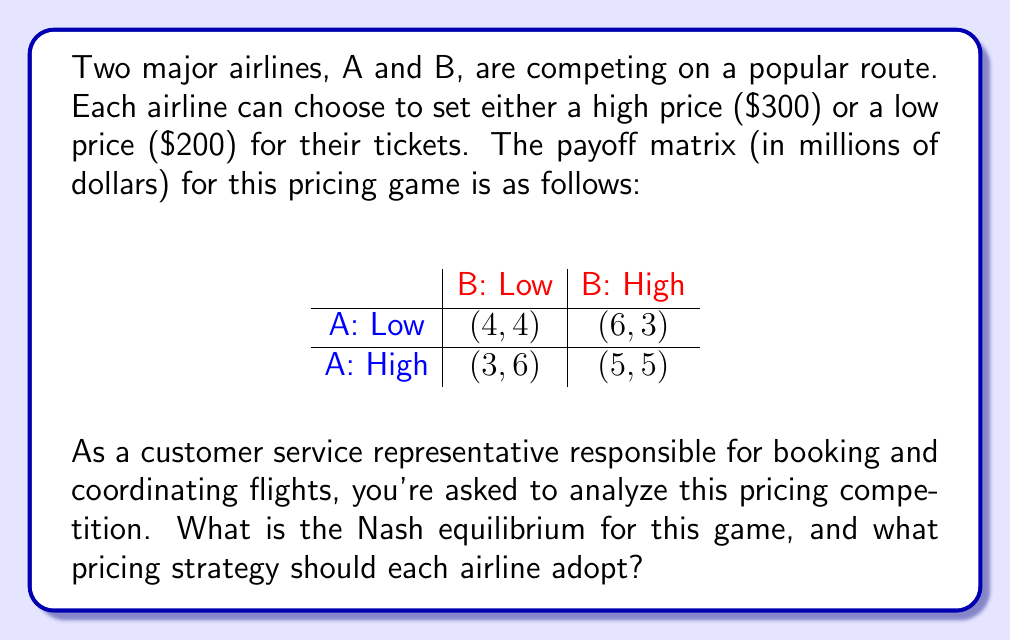Help me with this question. To find the Nash equilibrium, we need to identify the strategy profile where neither airline can unilaterally improve its payoff by changing its strategy.

Let's analyze each airline's best response to the other's strategies:

1. If Airline B chooses Low:
   - Airline A's payoff: Low (4) vs High (3)
   - Airline A's best response: Low

2. If Airline B chooses High:
   - Airline A's payoff: Low (6) vs High (5)
   - Airline A's best response: Low

3. If Airline A chooses Low:
   - Airline B's payoff: Low (4) vs High (3)
   - Airline B's best response: Low

4. If Airline A chooses High:
   - Airline B's payoff: Low (6) vs High (5)
   - Airline B's best response: Low

We can see that regardless of what the other airline does, each airline's best strategy is to choose Low pricing. This means that the strategy profile (Low, Low) is a Nash equilibrium.

To verify, let's check if any airline can improve by unilaterally changing its strategy:

- If Airline A switches to High while B stays Low: $4 > 3$, so no improvement.
- If Airline B switches to High while A stays Low: $4 > 3$, so no improvement.

Therefore, (Low, Low) is indeed a Nash equilibrium, and it's the only one in this game.
Answer: The Nash equilibrium for this airline pricing competition is (Low, Low), where both airlines should adopt the low pricing strategy of $200 per ticket. 